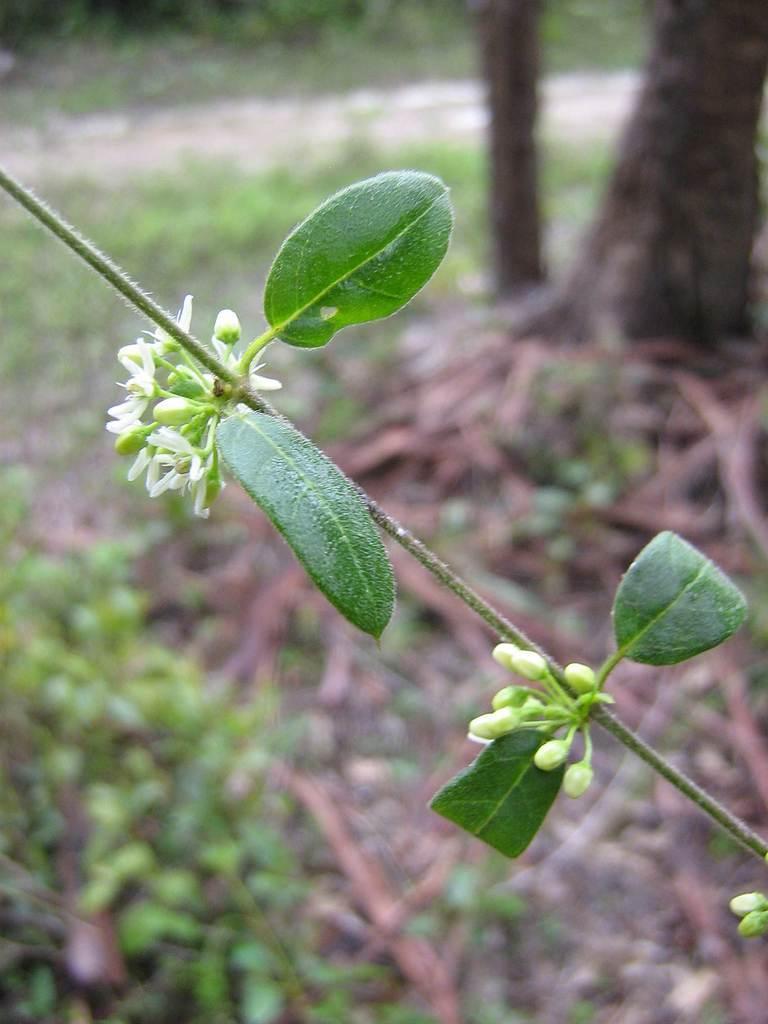In one or two sentences, can you explain what this image depicts? In this image we can see leaves and some flowers and in the background image is blur. 